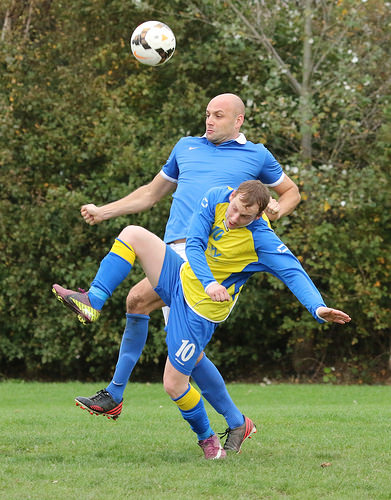<image>
Can you confirm if the man is in front of the man? No. The man is not in front of the man. The spatial positioning shows a different relationship between these objects. 